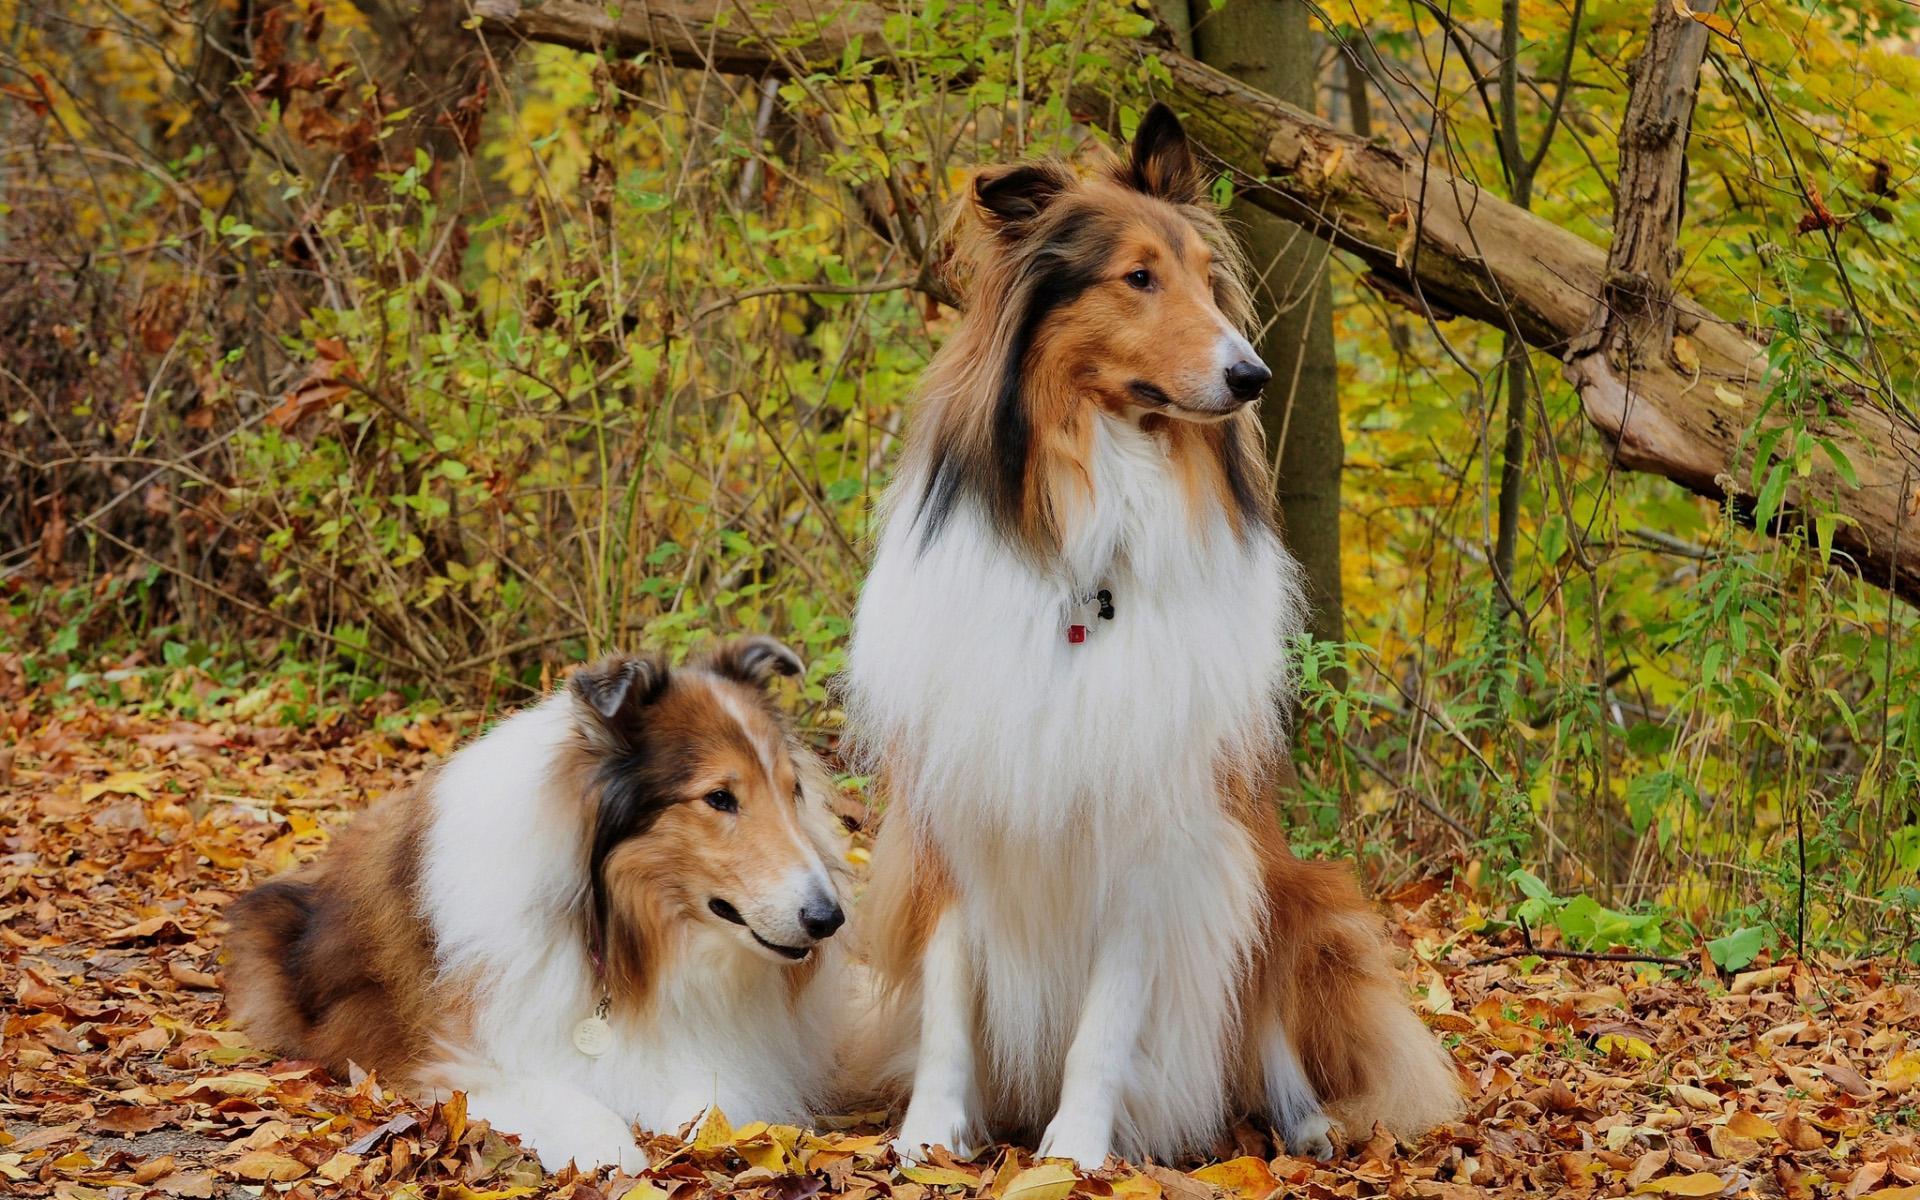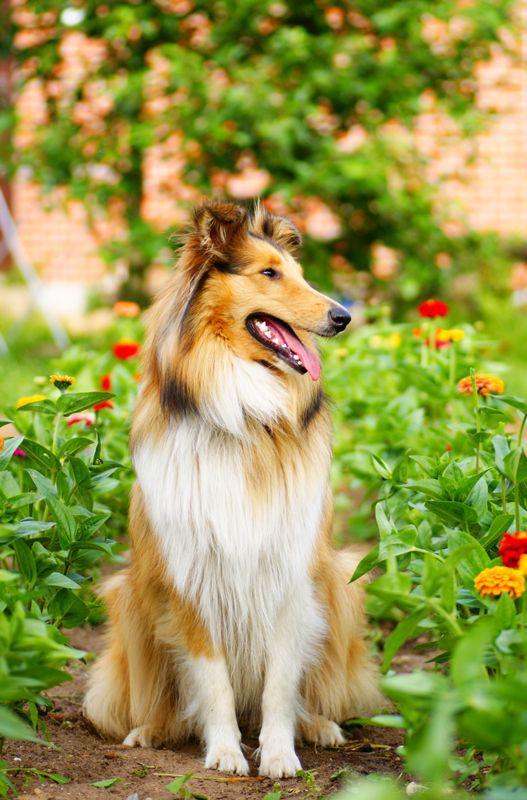The first image is the image on the left, the second image is the image on the right. Evaluate the accuracy of this statement regarding the images: "Young collies are posed sitting upright side-by-side in one image, and the other image shows one collie reclining with its head upright.". Is it true? Answer yes or no. No. The first image is the image on the left, the second image is the image on the right. Considering the images on both sides, is "The left image contains exactly two dogs." valid? Answer yes or no. Yes. 